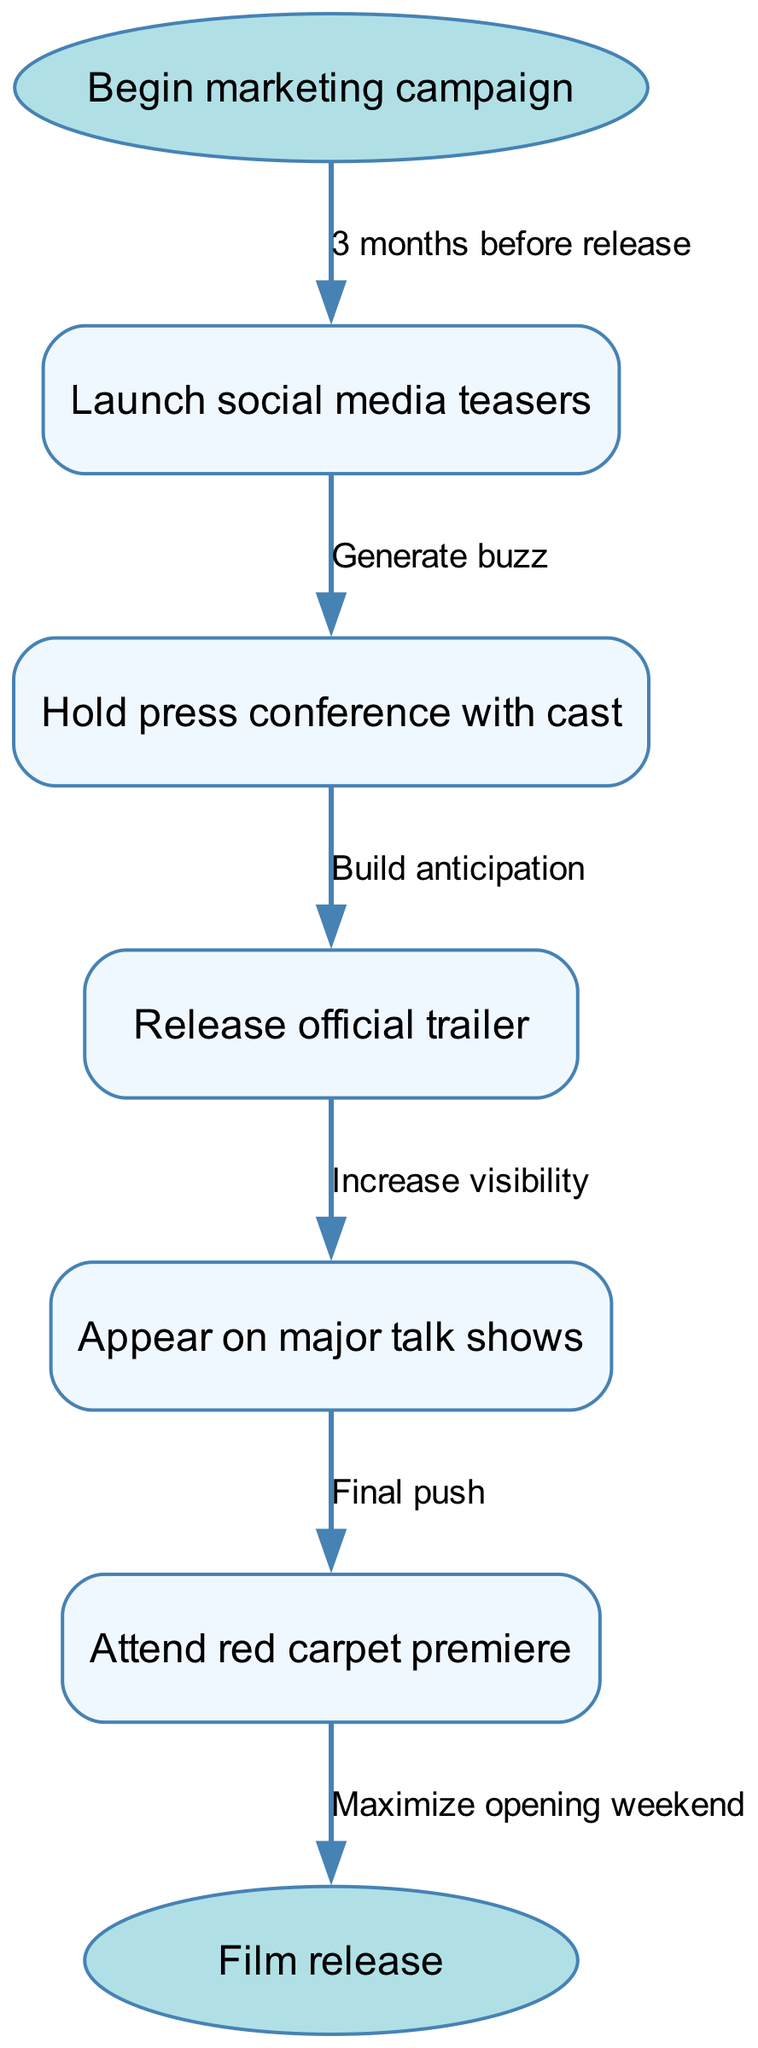What is the first step in the marketing campaign? The diagram shows that the first step is labeled as "Begin marketing campaign." This indicates the starting point of the entire process.
Answer: Begin marketing campaign How many nodes are there in the flowchart? By counting each unique point of action within the diagram, we identify a total of 7 nodes, including the start and end points.
Answer: 7 What action follows the social media teasers? The flowchart specifies that after launching social media teasers, the next action is to "Hold press conference with cast." This directly links the two stages in the campaign.
Answer: Hold press conference with cast What is the purpose of the press conference? According to the diagram, the press conference's purpose is to "Build anticipation," which connects this action with its intended outcome in the marketing plan.
Answer: Build anticipation Which node comes before attending the red carpet premiere? The diagram clearly shows that "Appear on major talk shows" is the action that occurs immediately prior to the "Attend red carpet premiere," indicating its sequential importance in the process.
Answer: Appear on major talk shows What is the last node in the flowchart? By examining the structure of the flowchart, we can see that the last action listed is "Film release," marking the conclusion of the marketing campaign.
Answer: Film release How does the trailer release contribute to the campaign? The diagram notes that releasing the trailer is aimed to "Increase visibility." This shows the expected outcome of this particular node in the marketing strategy.
Answer: Increase visibility What is the connection between the premiere and the film release? The flowchart denotes that the premiere's role is to "Maximize opening weekend," leading directly into the final node of "Film release," linking the two actions together.
Answer: Maximize opening weekend 